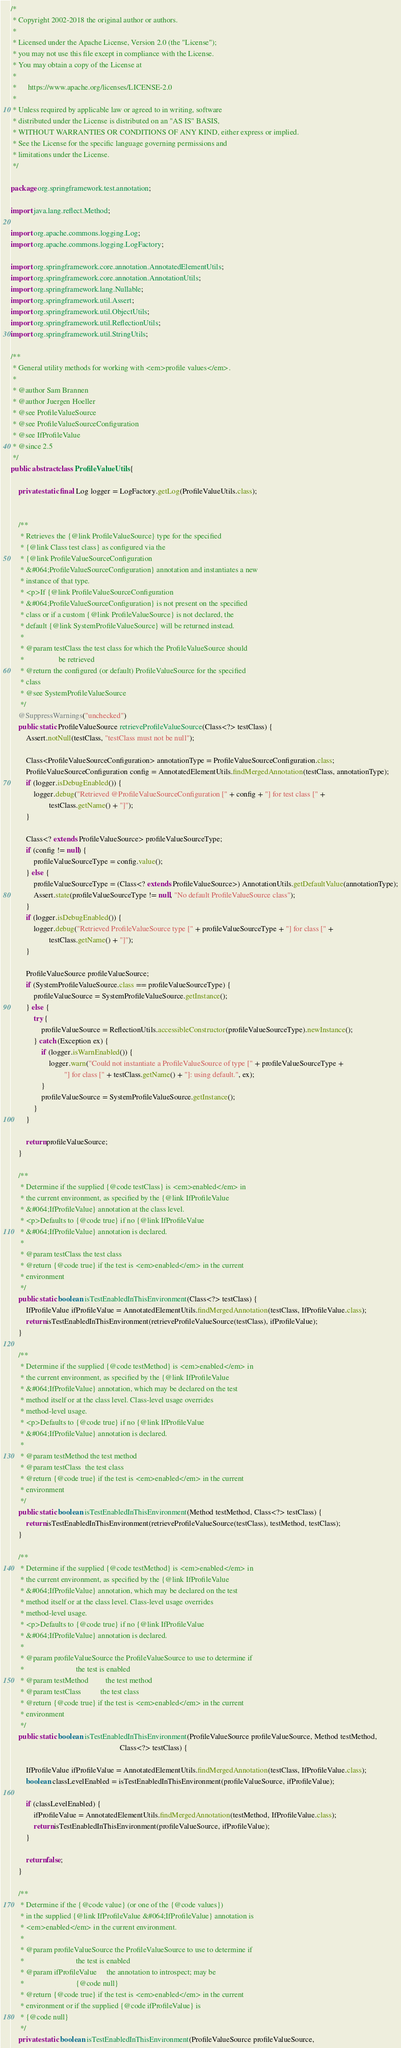<code> <loc_0><loc_0><loc_500><loc_500><_Java_>/*
 * Copyright 2002-2018 the original author or authors.
 *
 * Licensed under the Apache License, Version 2.0 (the "License");
 * you may not use this file except in compliance with the License.
 * You may obtain a copy of the License at
 *
 *      https://www.apache.org/licenses/LICENSE-2.0
 *
 * Unless required by applicable law or agreed to in writing, software
 * distributed under the License is distributed on an "AS IS" BASIS,
 * WITHOUT WARRANTIES OR CONDITIONS OF ANY KIND, either express or implied.
 * See the License for the specific language governing permissions and
 * limitations under the License.
 */

package org.springframework.test.annotation;

import java.lang.reflect.Method;

import org.apache.commons.logging.Log;
import org.apache.commons.logging.LogFactory;

import org.springframework.core.annotation.AnnotatedElementUtils;
import org.springframework.core.annotation.AnnotationUtils;
import org.springframework.lang.Nullable;
import org.springframework.util.Assert;
import org.springframework.util.ObjectUtils;
import org.springframework.util.ReflectionUtils;
import org.springframework.util.StringUtils;

/**
 * General utility methods for working with <em>profile values</em>.
 *
 * @author Sam Brannen
 * @author Juergen Hoeller
 * @see ProfileValueSource
 * @see ProfileValueSourceConfiguration
 * @see IfProfileValue
 * @since 2.5
 */
public abstract class ProfileValueUtils {

	private static final Log logger = LogFactory.getLog(ProfileValueUtils.class);


	/**
	 * Retrieves the {@link ProfileValueSource} type for the specified
	 * {@link Class test class} as configured via the
	 * {@link ProfileValueSourceConfiguration
	 * &#064;ProfileValueSourceConfiguration} annotation and instantiates a new
	 * instance of that type.
	 * <p>If {@link ProfileValueSourceConfiguration
	 * &#064;ProfileValueSourceConfiguration} is not present on the specified
	 * class or if a custom {@link ProfileValueSource} is not declared, the
	 * default {@link SystemProfileValueSource} will be returned instead.
	 *
	 * @param testClass the test class for which the ProfileValueSource should
	 *                  be retrieved
	 * @return the configured (or default) ProfileValueSource for the specified
	 * class
	 * @see SystemProfileValueSource
	 */
	@SuppressWarnings("unchecked")
	public static ProfileValueSource retrieveProfileValueSource(Class<?> testClass) {
		Assert.notNull(testClass, "testClass must not be null");

		Class<ProfileValueSourceConfiguration> annotationType = ProfileValueSourceConfiguration.class;
		ProfileValueSourceConfiguration config = AnnotatedElementUtils.findMergedAnnotation(testClass, annotationType);
		if (logger.isDebugEnabled()) {
			logger.debug("Retrieved @ProfileValueSourceConfiguration [" + config + "] for test class [" +
					testClass.getName() + "]");
		}

		Class<? extends ProfileValueSource> profileValueSourceType;
		if (config != null) {
			profileValueSourceType = config.value();
		} else {
			profileValueSourceType = (Class<? extends ProfileValueSource>) AnnotationUtils.getDefaultValue(annotationType);
			Assert.state(profileValueSourceType != null, "No default ProfileValueSource class");
		}
		if (logger.isDebugEnabled()) {
			logger.debug("Retrieved ProfileValueSource type [" + profileValueSourceType + "] for class [" +
					testClass.getName() + "]");
		}

		ProfileValueSource profileValueSource;
		if (SystemProfileValueSource.class == profileValueSourceType) {
			profileValueSource = SystemProfileValueSource.getInstance();
		} else {
			try {
				profileValueSource = ReflectionUtils.accessibleConstructor(profileValueSourceType).newInstance();
			} catch (Exception ex) {
				if (logger.isWarnEnabled()) {
					logger.warn("Could not instantiate a ProfileValueSource of type [" + profileValueSourceType +
							"] for class [" + testClass.getName() + "]: using default.", ex);
				}
				profileValueSource = SystemProfileValueSource.getInstance();
			}
		}

		return profileValueSource;
	}

	/**
	 * Determine if the supplied {@code testClass} is <em>enabled</em> in
	 * the current environment, as specified by the {@link IfProfileValue
	 * &#064;IfProfileValue} annotation at the class level.
	 * <p>Defaults to {@code true} if no {@link IfProfileValue
	 * &#064;IfProfileValue} annotation is declared.
	 *
	 * @param testClass the test class
	 * @return {@code true} if the test is <em>enabled</em> in the current
	 * environment
	 */
	public static boolean isTestEnabledInThisEnvironment(Class<?> testClass) {
		IfProfileValue ifProfileValue = AnnotatedElementUtils.findMergedAnnotation(testClass, IfProfileValue.class);
		return isTestEnabledInThisEnvironment(retrieveProfileValueSource(testClass), ifProfileValue);
	}

	/**
	 * Determine if the supplied {@code testMethod} is <em>enabled</em> in
	 * the current environment, as specified by the {@link IfProfileValue
	 * &#064;IfProfileValue} annotation, which may be declared on the test
	 * method itself or at the class level. Class-level usage overrides
	 * method-level usage.
	 * <p>Defaults to {@code true} if no {@link IfProfileValue
	 * &#064;IfProfileValue} annotation is declared.
	 *
	 * @param testMethod the test method
	 * @param testClass  the test class
	 * @return {@code true} if the test is <em>enabled</em> in the current
	 * environment
	 */
	public static boolean isTestEnabledInThisEnvironment(Method testMethod, Class<?> testClass) {
		return isTestEnabledInThisEnvironment(retrieveProfileValueSource(testClass), testMethod, testClass);
	}

	/**
	 * Determine if the supplied {@code testMethod} is <em>enabled</em> in
	 * the current environment, as specified by the {@link IfProfileValue
	 * &#064;IfProfileValue} annotation, which may be declared on the test
	 * method itself or at the class level. Class-level usage overrides
	 * method-level usage.
	 * <p>Defaults to {@code true} if no {@link IfProfileValue
	 * &#064;IfProfileValue} annotation is declared.
	 *
	 * @param profileValueSource the ProfileValueSource to use to determine if
	 *                           the test is enabled
	 * @param testMethod         the test method
	 * @param testClass          the test class
	 * @return {@code true} if the test is <em>enabled</em> in the current
	 * environment
	 */
	public static boolean isTestEnabledInThisEnvironment(ProfileValueSource profileValueSource, Method testMethod,
														 Class<?> testClass) {

		IfProfileValue ifProfileValue = AnnotatedElementUtils.findMergedAnnotation(testClass, IfProfileValue.class);
		boolean classLevelEnabled = isTestEnabledInThisEnvironment(profileValueSource, ifProfileValue);

		if (classLevelEnabled) {
			ifProfileValue = AnnotatedElementUtils.findMergedAnnotation(testMethod, IfProfileValue.class);
			return isTestEnabledInThisEnvironment(profileValueSource, ifProfileValue);
		}

		return false;
	}

	/**
	 * Determine if the {@code value} (or one of the {@code values})
	 * in the supplied {@link IfProfileValue &#064;IfProfileValue} annotation is
	 * <em>enabled</em> in the current environment.
	 *
	 * @param profileValueSource the ProfileValueSource to use to determine if
	 *                           the test is enabled
	 * @param ifProfileValue     the annotation to introspect; may be
	 *                           {@code null}
	 * @return {@code true} if the test is <em>enabled</em> in the current
	 * environment or if the supplied {@code ifProfileValue} is
	 * {@code null}
	 */
	private static boolean isTestEnabledInThisEnvironment(ProfileValueSource profileValueSource,</code> 